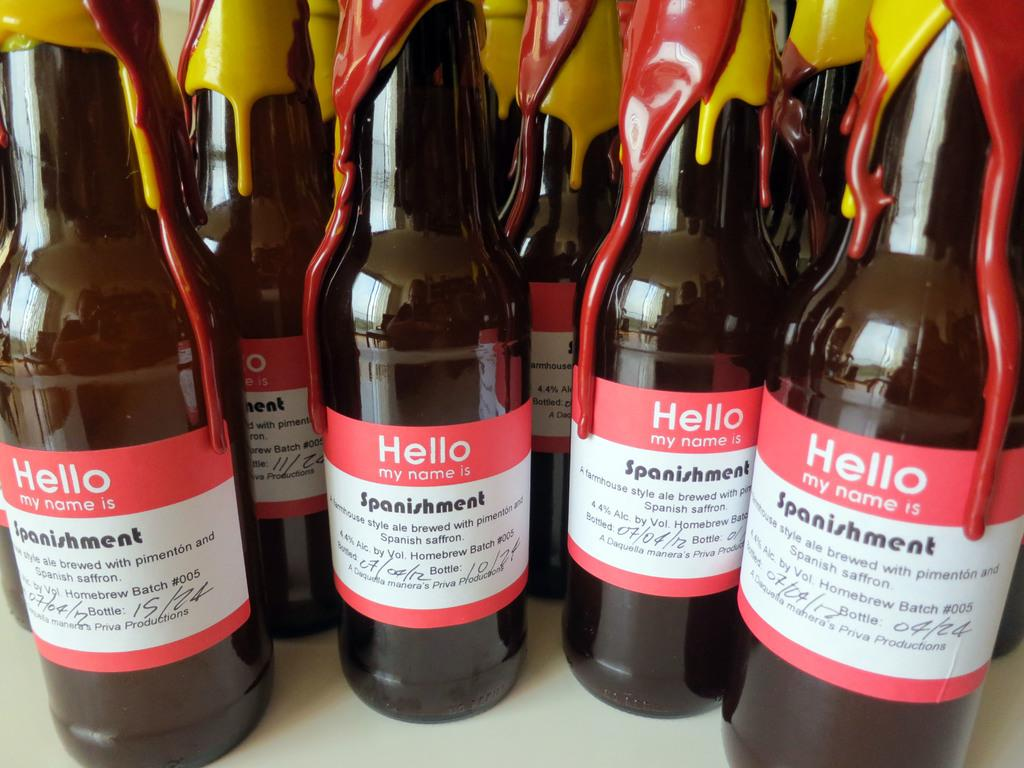<image>
Relay a brief, clear account of the picture shown. Four bottles of beer which read 'hello my name is' 